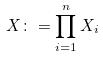<formula> <loc_0><loc_0><loc_500><loc_500>X \colon = \prod _ { i = 1 } ^ { n } X _ { i }</formula> 